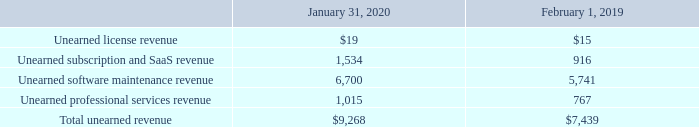Unearned Revenue
Unearned revenue as of the periods presented consisted of the following (table in millions):
Unearned subscription and SaaS revenue is generally recognized over time as customers consume the services or ratably over the term of the subscription, commencing upon provisioning of the service. Previously, unearned subscription and SaaS revenue was allocated between unearned license revenue and unearned software maintenance revenue in prior periods and has been reclassified to conform with current period presentation.
Unearned software maintenance revenue is attributable to VMware’s maintenance contracts and is generally recognized over time on a ratable basis over the contract duration. The weighted-average remaining contractual term as of January 31, 2020 was approximately two years. Unearned professional services revenue results primarily from prepaid professional services and is generally recognized as the services are performed.
Total billings and revenue recognized during the year ended January 31, 2020, were $8.1 billion and $6.4 billion, respectively, and did not include amounts for performance obligations that were fully satisfied upon delivery, such as on-premise licenses. During the year ended January 31, 2020, VMware assumed $154 million in unearned revenue in the acquisition of Carbon Black, Inc. (“Carbon Black”).
Total billings and revenue recognized during the year ended February 1, 2019, were $6.9 billion and $5.5 billion, respectively, and did not include amounts for performance obligations that were fully satisfied upon delivery, such as on-premise licenses.
Revenue recognized during the year ended February 2, 2018 was $4.8 billion and did not include amounts for performance obligations that were fully satisfied upon delivery, such as on-premise licenses.
What was unearned software maintenance revenue attributable to? Vmware’s maintenance contracts. What is unearned professional services revenue the result of? Prepaid professional services and is generally recognized as the services are performed. What was the total billings recognized during the year ended 2020? $8.1 billion. What was the change in unearned license revenue between 2019 and 2020?
Answer scale should be: million. 19-15
Answer: 4. What was the change in Unearned software maintenance revenue between 2019 and 2020?
Answer scale should be: million. 6,700-5,741
Answer: 959. What was the percentage of total unearned revenue between 2019 and 2020?
Answer scale should be: percent. (9,268-7,439)/7,439
Answer: 24.59. 